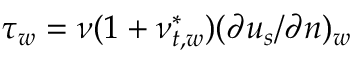<formula> <loc_0><loc_0><loc_500><loc_500>\tau _ { w } = \nu ( 1 + \nu _ { t , w } ^ { * } ) ( \partial { u _ { s } } / \partial { n } ) _ { w }</formula> 